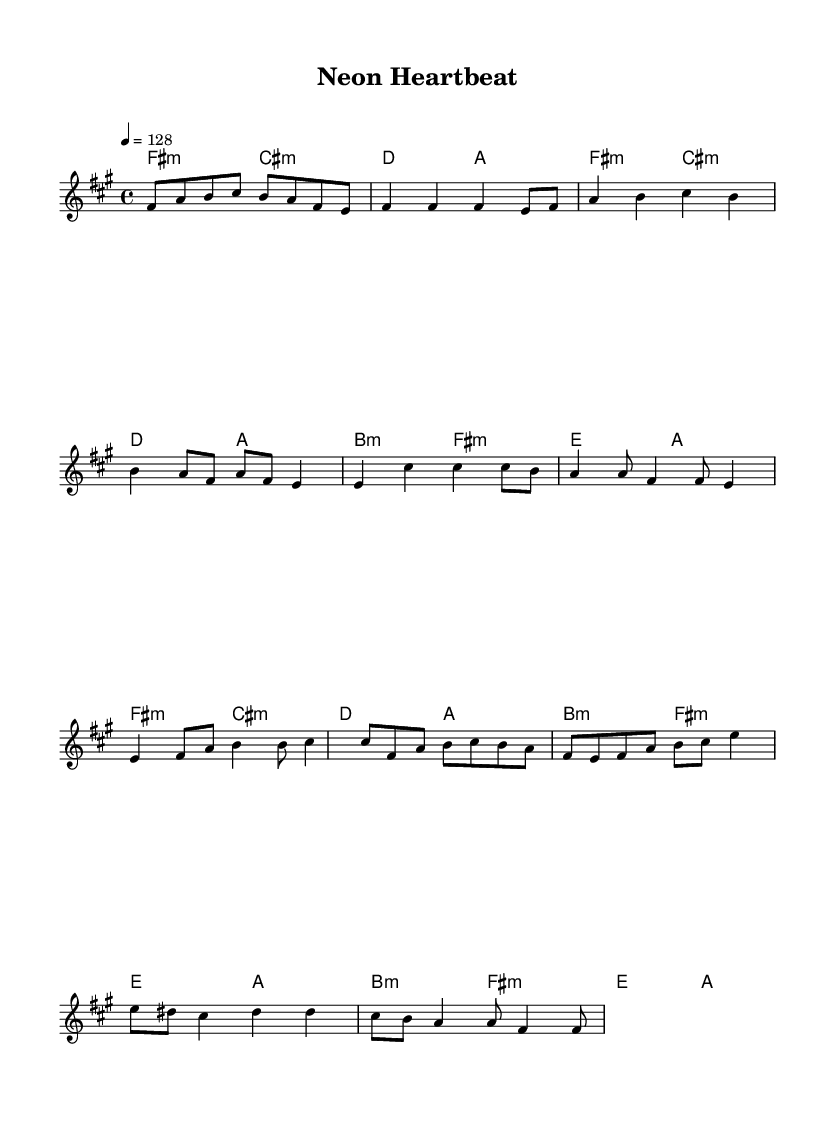What is the key signature of this music? The key signature is indicated in the `global` section of the sheet music, where it states `\key fis \minor`, meaning it has three sharps.
Answer: F sharp minor What is the time signature of this music? The time signature is found in the `global` section, represented as `\time 4/4`, indicating four beats per measure with a quarter note receiving one beat.
Answer: Four four What is the tempo marking of this piece? The tempo marking is also found in the `global` section, where it states `\tempo 4 = 128`. This means the quarter note is played at a speed of 128 beats per minute.
Answer: 128 How many measures are in the chorus section? By examining the melody for the chorus, we can count the measures: there are four measures in the chorus section.
Answer: Four What musical technique is primarily showcased in the pre-chorus section? The pre-chorus predominantly uses syncopation, especially noted in the eighth notes interspersed with quarter notes, creating a rhythmic tension leading into the chorus.
Answer: Syncopation What is a defining characteristic of K-Pop song structure seen in this piece? A defining feature is the alternating sections, such as verses followed by a pre-chorus and chorus, which create dynamic contrasts and emotional shifts typical in K-Pop music.
Answer: Alternating sections 